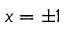<formula> <loc_0><loc_0><loc_500><loc_500>x = \pm 1</formula> 